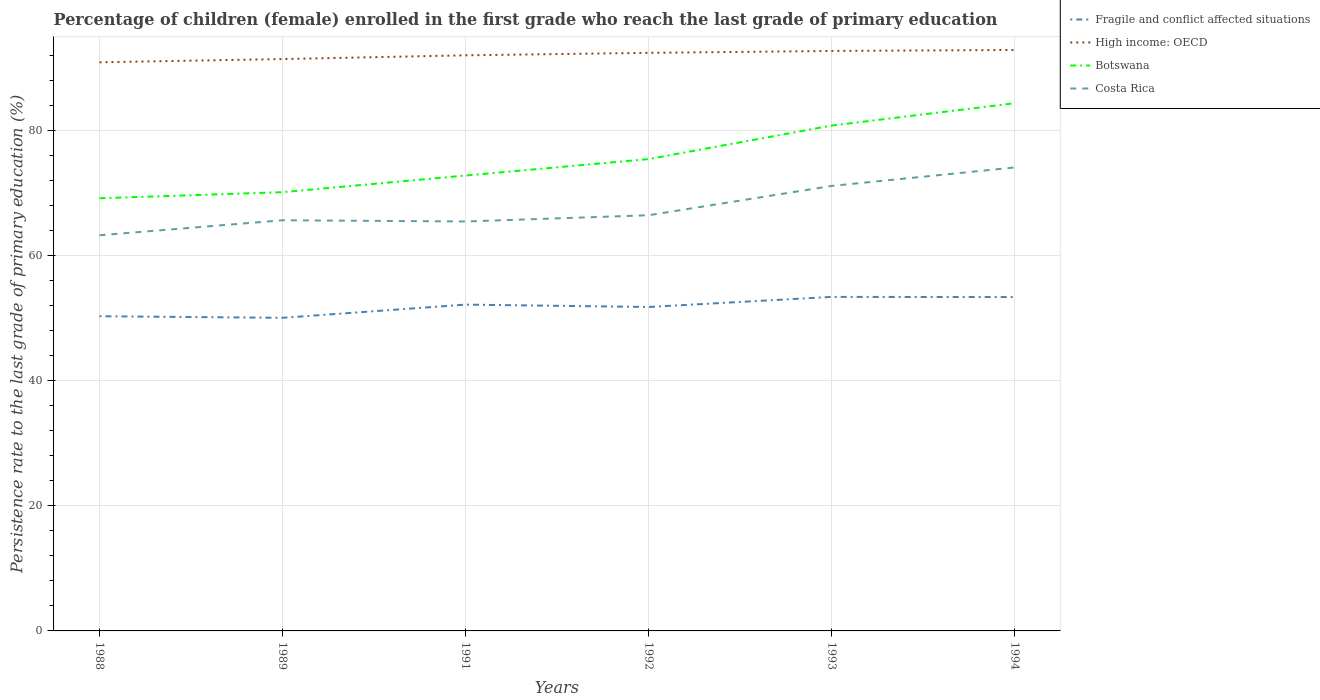How many different coloured lines are there?
Offer a very short reply. 4. Across all years, what is the maximum persistence rate of children in Botswana?
Ensure brevity in your answer.  69.21. In which year was the persistence rate of children in Fragile and conflict affected situations maximum?
Make the answer very short. 1989. What is the total persistence rate of children in Botswana in the graph?
Provide a succinct answer. -0.97. What is the difference between the highest and the second highest persistence rate of children in Botswana?
Offer a very short reply. 15.2. What is the difference between the highest and the lowest persistence rate of children in Fragile and conflict affected situations?
Your response must be concise. 3. What is the difference between two consecutive major ticks on the Y-axis?
Your answer should be very brief. 20. How are the legend labels stacked?
Give a very brief answer. Vertical. What is the title of the graph?
Offer a terse response. Percentage of children (female) enrolled in the first grade who reach the last grade of primary education. What is the label or title of the Y-axis?
Make the answer very short. Persistence rate to the last grade of primary education (%). What is the Persistence rate to the last grade of primary education (%) of Fragile and conflict affected situations in 1988?
Your response must be concise. 50.34. What is the Persistence rate to the last grade of primary education (%) in High income: OECD in 1988?
Provide a succinct answer. 90.96. What is the Persistence rate to the last grade of primary education (%) in Botswana in 1988?
Offer a very short reply. 69.21. What is the Persistence rate to the last grade of primary education (%) in Costa Rica in 1988?
Provide a succinct answer. 63.28. What is the Persistence rate to the last grade of primary education (%) in Fragile and conflict affected situations in 1989?
Ensure brevity in your answer.  50.08. What is the Persistence rate to the last grade of primary education (%) in High income: OECD in 1989?
Give a very brief answer. 91.47. What is the Persistence rate to the last grade of primary education (%) of Botswana in 1989?
Make the answer very short. 70.18. What is the Persistence rate to the last grade of primary education (%) in Costa Rica in 1989?
Offer a terse response. 65.69. What is the Persistence rate to the last grade of primary education (%) in Fragile and conflict affected situations in 1991?
Your response must be concise. 52.2. What is the Persistence rate to the last grade of primary education (%) of High income: OECD in 1991?
Offer a terse response. 92.07. What is the Persistence rate to the last grade of primary education (%) of Botswana in 1991?
Ensure brevity in your answer.  72.84. What is the Persistence rate to the last grade of primary education (%) of Costa Rica in 1991?
Provide a succinct answer. 65.49. What is the Persistence rate to the last grade of primary education (%) of Fragile and conflict affected situations in 1992?
Make the answer very short. 51.82. What is the Persistence rate to the last grade of primary education (%) in High income: OECD in 1992?
Offer a terse response. 92.47. What is the Persistence rate to the last grade of primary education (%) in Botswana in 1992?
Make the answer very short. 75.47. What is the Persistence rate to the last grade of primary education (%) in Costa Rica in 1992?
Your answer should be very brief. 66.49. What is the Persistence rate to the last grade of primary education (%) of Fragile and conflict affected situations in 1993?
Your answer should be compact. 53.43. What is the Persistence rate to the last grade of primary education (%) in High income: OECD in 1993?
Offer a terse response. 92.77. What is the Persistence rate to the last grade of primary education (%) of Botswana in 1993?
Your answer should be very brief. 80.83. What is the Persistence rate to the last grade of primary education (%) of Costa Rica in 1993?
Offer a very short reply. 71.18. What is the Persistence rate to the last grade of primary education (%) in Fragile and conflict affected situations in 1994?
Keep it short and to the point. 53.4. What is the Persistence rate to the last grade of primary education (%) in High income: OECD in 1994?
Provide a short and direct response. 92.93. What is the Persistence rate to the last grade of primary education (%) of Botswana in 1994?
Ensure brevity in your answer.  84.4. What is the Persistence rate to the last grade of primary education (%) in Costa Rica in 1994?
Ensure brevity in your answer.  74.13. Across all years, what is the maximum Persistence rate to the last grade of primary education (%) of Fragile and conflict affected situations?
Your answer should be compact. 53.43. Across all years, what is the maximum Persistence rate to the last grade of primary education (%) in High income: OECD?
Your answer should be compact. 92.93. Across all years, what is the maximum Persistence rate to the last grade of primary education (%) of Botswana?
Your answer should be very brief. 84.4. Across all years, what is the maximum Persistence rate to the last grade of primary education (%) of Costa Rica?
Your response must be concise. 74.13. Across all years, what is the minimum Persistence rate to the last grade of primary education (%) of Fragile and conflict affected situations?
Offer a terse response. 50.08. Across all years, what is the minimum Persistence rate to the last grade of primary education (%) in High income: OECD?
Offer a terse response. 90.96. Across all years, what is the minimum Persistence rate to the last grade of primary education (%) in Botswana?
Offer a very short reply. 69.21. Across all years, what is the minimum Persistence rate to the last grade of primary education (%) of Costa Rica?
Provide a succinct answer. 63.28. What is the total Persistence rate to the last grade of primary education (%) in Fragile and conflict affected situations in the graph?
Keep it short and to the point. 311.27. What is the total Persistence rate to the last grade of primary education (%) in High income: OECD in the graph?
Ensure brevity in your answer.  552.67. What is the total Persistence rate to the last grade of primary education (%) in Botswana in the graph?
Your answer should be very brief. 452.94. What is the total Persistence rate to the last grade of primary education (%) of Costa Rica in the graph?
Your answer should be very brief. 406.27. What is the difference between the Persistence rate to the last grade of primary education (%) in Fragile and conflict affected situations in 1988 and that in 1989?
Give a very brief answer. 0.26. What is the difference between the Persistence rate to the last grade of primary education (%) of High income: OECD in 1988 and that in 1989?
Provide a succinct answer. -0.51. What is the difference between the Persistence rate to the last grade of primary education (%) in Botswana in 1988 and that in 1989?
Keep it short and to the point. -0.97. What is the difference between the Persistence rate to the last grade of primary education (%) of Costa Rica in 1988 and that in 1989?
Keep it short and to the point. -2.4. What is the difference between the Persistence rate to the last grade of primary education (%) in Fragile and conflict affected situations in 1988 and that in 1991?
Your response must be concise. -1.86. What is the difference between the Persistence rate to the last grade of primary education (%) of High income: OECD in 1988 and that in 1991?
Offer a very short reply. -1.12. What is the difference between the Persistence rate to the last grade of primary education (%) in Botswana in 1988 and that in 1991?
Your answer should be compact. -3.64. What is the difference between the Persistence rate to the last grade of primary education (%) of Costa Rica in 1988 and that in 1991?
Make the answer very short. -2.21. What is the difference between the Persistence rate to the last grade of primary education (%) in Fragile and conflict affected situations in 1988 and that in 1992?
Your answer should be compact. -1.48. What is the difference between the Persistence rate to the last grade of primary education (%) in High income: OECD in 1988 and that in 1992?
Keep it short and to the point. -1.51. What is the difference between the Persistence rate to the last grade of primary education (%) of Botswana in 1988 and that in 1992?
Make the answer very short. -6.27. What is the difference between the Persistence rate to the last grade of primary education (%) in Costa Rica in 1988 and that in 1992?
Provide a short and direct response. -3.21. What is the difference between the Persistence rate to the last grade of primary education (%) in Fragile and conflict affected situations in 1988 and that in 1993?
Your answer should be very brief. -3.09. What is the difference between the Persistence rate to the last grade of primary education (%) in High income: OECD in 1988 and that in 1993?
Provide a short and direct response. -1.81. What is the difference between the Persistence rate to the last grade of primary education (%) of Botswana in 1988 and that in 1993?
Make the answer very short. -11.63. What is the difference between the Persistence rate to the last grade of primary education (%) of Costa Rica in 1988 and that in 1993?
Provide a succinct answer. -7.89. What is the difference between the Persistence rate to the last grade of primary education (%) of Fragile and conflict affected situations in 1988 and that in 1994?
Keep it short and to the point. -3.06. What is the difference between the Persistence rate to the last grade of primary education (%) of High income: OECD in 1988 and that in 1994?
Keep it short and to the point. -1.97. What is the difference between the Persistence rate to the last grade of primary education (%) in Botswana in 1988 and that in 1994?
Keep it short and to the point. -15.2. What is the difference between the Persistence rate to the last grade of primary education (%) in Costa Rica in 1988 and that in 1994?
Provide a short and direct response. -10.85. What is the difference between the Persistence rate to the last grade of primary education (%) in Fragile and conflict affected situations in 1989 and that in 1991?
Your response must be concise. -2.11. What is the difference between the Persistence rate to the last grade of primary education (%) in High income: OECD in 1989 and that in 1991?
Provide a succinct answer. -0.6. What is the difference between the Persistence rate to the last grade of primary education (%) of Botswana in 1989 and that in 1991?
Ensure brevity in your answer.  -2.66. What is the difference between the Persistence rate to the last grade of primary education (%) in Costa Rica in 1989 and that in 1991?
Your response must be concise. 0.2. What is the difference between the Persistence rate to the last grade of primary education (%) in Fragile and conflict affected situations in 1989 and that in 1992?
Ensure brevity in your answer.  -1.73. What is the difference between the Persistence rate to the last grade of primary education (%) in High income: OECD in 1989 and that in 1992?
Your response must be concise. -0.99. What is the difference between the Persistence rate to the last grade of primary education (%) in Botswana in 1989 and that in 1992?
Your answer should be compact. -5.29. What is the difference between the Persistence rate to the last grade of primary education (%) of Costa Rica in 1989 and that in 1992?
Provide a short and direct response. -0.8. What is the difference between the Persistence rate to the last grade of primary education (%) of Fragile and conflict affected situations in 1989 and that in 1993?
Offer a very short reply. -3.35. What is the difference between the Persistence rate to the last grade of primary education (%) in High income: OECD in 1989 and that in 1993?
Offer a terse response. -1.3. What is the difference between the Persistence rate to the last grade of primary education (%) of Botswana in 1989 and that in 1993?
Ensure brevity in your answer.  -10.65. What is the difference between the Persistence rate to the last grade of primary education (%) of Costa Rica in 1989 and that in 1993?
Your response must be concise. -5.49. What is the difference between the Persistence rate to the last grade of primary education (%) of Fragile and conflict affected situations in 1989 and that in 1994?
Your response must be concise. -3.32. What is the difference between the Persistence rate to the last grade of primary education (%) of High income: OECD in 1989 and that in 1994?
Give a very brief answer. -1.46. What is the difference between the Persistence rate to the last grade of primary education (%) in Botswana in 1989 and that in 1994?
Your response must be concise. -14.22. What is the difference between the Persistence rate to the last grade of primary education (%) of Costa Rica in 1989 and that in 1994?
Ensure brevity in your answer.  -8.44. What is the difference between the Persistence rate to the last grade of primary education (%) of Fragile and conflict affected situations in 1991 and that in 1992?
Your answer should be very brief. 0.38. What is the difference between the Persistence rate to the last grade of primary education (%) in High income: OECD in 1991 and that in 1992?
Your response must be concise. -0.39. What is the difference between the Persistence rate to the last grade of primary education (%) in Botswana in 1991 and that in 1992?
Provide a short and direct response. -2.63. What is the difference between the Persistence rate to the last grade of primary education (%) in Costa Rica in 1991 and that in 1992?
Keep it short and to the point. -1. What is the difference between the Persistence rate to the last grade of primary education (%) of Fragile and conflict affected situations in 1991 and that in 1993?
Provide a succinct answer. -1.23. What is the difference between the Persistence rate to the last grade of primary education (%) in High income: OECD in 1991 and that in 1993?
Your answer should be compact. -0.7. What is the difference between the Persistence rate to the last grade of primary education (%) in Botswana in 1991 and that in 1993?
Your answer should be compact. -7.99. What is the difference between the Persistence rate to the last grade of primary education (%) of Costa Rica in 1991 and that in 1993?
Give a very brief answer. -5.68. What is the difference between the Persistence rate to the last grade of primary education (%) of Fragile and conflict affected situations in 1991 and that in 1994?
Your answer should be very brief. -1.21. What is the difference between the Persistence rate to the last grade of primary education (%) in High income: OECD in 1991 and that in 1994?
Your answer should be very brief. -0.85. What is the difference between the Persistence rate to the last grade of primary education (%) in Botswana in 1991 and that in 1994?
Ensure brevity in your answer.  -11.56. What is the difference between the Persistence rate to the last grade of primary education (%) in Costa Rica in 1991 and that in 1994?
Your answer should be very brief. -8.64. What is the difference between the Persistence rate to the last grade of primary education (%) of Fragile and conflict affected situations in 1992 and that in 1993?
Provide a succinct answer. -1.61. What is the difference between the Persistence rate to the last grade of primary education (%) of High income: OECD in 1992 and that in 1993?
Your answer should be very brief. -0.3. What is the difference between the Persistence rate to the last grade of primary education (%) of Botswana in 1992 and that in 1993?
Your answer should be compact. -5.36. What is the difference between the Persistence rate to the last grade of primary education (%) in Costa Rica in 1992 and that in 1993?
Make the answer very short. -4.69. What is the difference between the Persistence rate to the last grade of primary education (%) in Fragile and conflict affected situations in 1992 and that in 1994?
Give a very brief answer. -1.59. What is the difference between the Persistence rate to the last grade of primary education (%) in High income: OECD in 1992 and that in 1994?
Give a very brief answer. -0.46. What is the difference between the Persistence rate to the last grade of primary education (%) in Botswana in 1992 and that in 1994?
Provide a succinct answer. -8.93. What is the difference between the Persistence rate to the last grade of primary education (%) of Costa Rica in 1992 and that in 1994?
Ensure brevity in your answer.  -7.64. What is the difference between the Persistence rate to the last grade of primary education (%) in Fragile and conflict affected situations in 1993 and that in 1994?
Give a very brief answer. 0.03. What is the difference between the Persistence rate to the last grade of primary education (%) in High income: OECD in 1993 and that in 1994?
Provide a short and direct response. -0.16. What is the difference between the Persistence rate to the last grade of primary education (%) of Botswana in 1993 and that in 1994?
Offer a terse response. -3.57. What is the difference between the Persistence rate to the last grade of primary education (%) of Costa Rica in 1993 and that in 1994?
Offer a very short reply. -2.96. What is the difference between the Persistence rate to the last grade of primary education (%) in Fragile and conflict affected situations in 1988 and the Persistence rate to the last grade of primary education (%) in High income: OECD in 1989?
Ensure brevity in your answer.  -41.13. What is the difference between the Persistence rate to the last grade of primary education (%) of Fragile and conflict affected situations in 1988 and the Persistence rate to the last grade of primary education (%) of Botswana in 1989?
Your answer should be compact. -19.84. What is the difference between the Persistence rate to the last grade of primary education (%) in Fragile and conflict affected situations in 1988 and the Persistence rate to the last grade of primary education (%) in Costa Rica in 1989?
Provide a short and direct response. -15.35. What is the difference between the Persistence rate to the last grade of primary education (%) in High income: OECD in 1988 and the Persistence rate to the last grade of primary education (%) in Botswana in 1989?
Provide a succinct answer. 20.78. What is the difference between the Persistence rate to the last grade of primary education (%) of High income: OECD in 1988 and the Persistence rate to the last grade of primary education (%) of Costa Rica in 1989?
Your response must be concise. 25.27. What is the difference between the Persistence rate to the last grade of primary education (%) of Botswana in 1988 and the Persistence rate to the last grade of primary education (%) of Costa Rica in 1989?
Provide a short and direct response. 3.52. What is the difference between the Persistence rate to the last grade of primary education (%) in Fragile and conflict affected situations in 1988 and the Persistence rate to the last grade of primary education (%) in High income: OECD in 1991?
Your answer should be very brief. -41.73. What is the difference between the Persistence rate to the last grade of primary education (%) of Fragile and conflict affected situations in 1988 and the Persistence rate to the last grade of primary education (%) of Botswana in 1991?
Offer a terse response. -22.5. What is the difference between the Persistence rate to the last grade of primary education (%) of Fragile and conflict affected situations in 1988 and the Persistence rate to the last grade of primary education (%) of Costa Rica in 1991?
Your answer should be compact. -15.15. What is the difference between the Persistence rate to the last grade of primary education (%) of High income: OECD in 1988 and the Persistence rate to the last grade of primary education (%) of Botswana in 1991?
Offer a terse response. 18.12. What is the difference between the Persistence rate to the last grade of primary education (%) in High income: OECD in 1988 and the Persistence rate to the last grade of primary education (%) in Costa Rica in 1991?
Your response must be concise. 25.46. What is the difference between the Persistence rate to the last grade of primary education (%) of Botswana in 1988 and the Persistence rate to the last grade of primary education (%) of Costa Rica in 1991?
Make the answer very short. 3.71. What is the difference between the Persistence rate to the last grade of primary education (%) of Fragile and conflict affected situations in 1988 and the Persistence rate to the last grade of primary education (%) of High income: OECD in 1992?
Your response must be concise. -42.13. What is the difference between the Persistence rate to the last grade of primary education (%) of Fragile and conflict affected situations in 1988 and the Persistence rate to the last grade of primary education (%) of Botswana in 1992?
Your response must be concise. -25.13. What is the difference between the Persistence rate to the last grade of primary education (%) of Fragile and conflict affected situations in 1988 and the Persistence rate to the last grade of primary education (%) of Costa Rica in 1992?
Ensure brevity in your answer.  -16.15. What is the difference between the Persistence rate to the last grade of primary education (%) of High income: OECD in 1988 and the Persistence rate to the last grade of primary education (%) of Botswana in 1992?
Offer a very short reply. 15.49. What is the difference between the Persistence rate to the last grade of primary education (%) of High income: OECD in 1988 and the Persistence rate to the last grade of primary education (%) of Costa Rica in 1992?
Your answer should be very brief. 24.47. What is the difference between the Persistence rate to the last grade of primary education (%) in Botswana in 1988 and the Persistence rate to the last grade of primary education (%) in Costa Rica in 1992?
Keep it short and to the point. 2.72. What is the difference between the Persistence rate to the last grade of primary education (%) of Fragile and conflict affected situations in 1988 and the Persistence rate to the last grade of primary education (%) of High income: OECD in 1993?
Your answer should be very brief. -42.43. What is the difference between the Persistence rate to the last grade of primary education (%) of Fragile and conflict affected situations in 1988 and the Persistence rate to the last grade of primary education (%) of Botswana in 1993?
Your answer should be compact. -30.49. What is the difference between the Persistence rate to the last grade of primary education (%) of Fragile and conflict affected situations in 1988 and the Persistence rate to the last grade of primary education (%) of Costa Rica in 1993?
Your answer should be compact. -20.84. What is the difference between the Persistence rate to the last grade of primary education (%) of High income: OECD in 1988 and the Persistence rate to the last grade of primary education (%) of Botswana in 1993?
Provide a succinct answer. 10.12. What is the difference between the Persistence rate to the last grade of primary education (%) in High income: OECD in 1988 and the Persistence rate to the last grade of primary education (%) in Costa Rica in 1993?
Provide a succinct answer. 19.78. What is the difference between the Persistence rate to the last grade of primary education (%) of Botswana in 1988 and the Persistence rate to the last grade of primary education (%) of Costa Rica in 1993?
Your answer should be very brief. -1.97. What is the difference between the Persistence rate to the last grade of primary education (%) of Fragile and conflict affected situations in 1988 and the Persistence rate to the last grade of primary education (%) of High income: OECD in 1994?
Offer a very short reply. -42.59. What is the difference between the Persistence rate to the last grade of primary education (%) in Fragile and conflict affected situations in 1988 and the Persistence rate to the last grade of primary education (%) in Botswana in 1994?
Ensure brevity in your answer.  -34.07. What is the difference between the Persistence rate to the last grade of primary education (%) of Fragile and conflict affected situations in 1988 and the Persistence rate to the last grade of primary education (%) of Costa Rica in 1994?
Make the answer very short. -23.79. What is the difference between the Persistence rate to the last grade of primary education (%) in High income: OECD in 1988 and the Persistence rate to the last grade of primary education (%) in Botswana in 1994?
Your answer should be very brief. 6.55. What is the difference between the Persistence rate to the last grade of primary education (%) in High income: OECD in 1988 and the Persistence rate to the last grade of primary education (%) in Costa Rica in 1994?
Offer a very short reply. 16.83. What is the difference between the Persistence rate to the last grade of primary education (%) of Botswana in 1988 and the Persistence rate to the last grade of primary education (%) of Costa Rica in 1994?
Give a very brief answer. -4.93. What is the difference between the Persistence rate to the last grade of primary education (%) of Fragile and conflict affected situations in 1989 and the Persistence rate to the last grade of primary education (%) of High income: OECD in 1991?
Provide a succinct answer. -41.99. What is the difference between the Persistence rate to the last grade of primary education (%) in Fragile and conflict affected situations in 1989 and the Persistence rate to the last grade of primary education (%) in Botswana in 1991?
Provide a succinct answer. -22.76. What is the difference between the Persistence rate to the last grade of primary education (%) in Fragile and conflict affected situations in 1989 and the Persistence rate to the last grade of primary education (%) in Costa Rica in 1991?
Offer a terse response. -15.41. What is the difference between the Persistence rate to the last grade of primary education (%) of High income: OECD in 1989 and the Persistence rate to the last grade of primary education (%) of Botswana in 1991?
Your answer should be very brief. 18.63. What is the difference between the Persistence rate to the last grade of primary education (%) of High income: OECD in 1989 and the Persistence rate to the last grade of primary education (%) of Costa Rica in 1991?
Provide a succinct answer. 25.98. What is the difference between the Persistence rate to the last grade of primary education (%) of Botswana in 1989 and the Persistence rate to the last grade of primary education (%) of Costa Rica in 1991?
Provide a succinct answer. 4.69. What is the difference between the Persistence rate to the last grade of primary education (%) in Fragile and conflict affected situations in 1989 and the Persistence rate to the last grade of primary education (%) in High income: OECD in 1992?
Make the answer very short. -42.38. What is the difference between the Persistence rate to the last grade of primary education (%) of Fragile and conflict affected situations in 1989 and the Persistence rate to the last grade of primary education (%) of Botswana in 1992?
Provide a succinct answer. -25.39. What is the difference between the Persistence rate to the last grade of primary education (%) in Fragile and conflict affected situations in 1989 and the Persistence rate to the last grade of primary education (%) in Costa Rica in 1992?
Offer a very short reply. -16.41. What is the difference between the Persistence rate to the last grade of primary education (%) in High income: OECD in 1989 and the Persistence rate to the last grade of primary education (%) in Botswana in 1992?
Offer a very short reply. 16. What is the difference between the Persistence rate to the last grade of primary education (%) of High income: OECD in 1989 and the Persistence rate to the last grade of primary education (%) of Costa Rica in 1992?
Provide a succinct answer. 24.98. What is the difference between the Persistence rate to the last grade of primary education (%) of Botswana in 1989 and the Persistence rate to the last grade of primary education (%) of Costa Rica in 1992?
Offer a very short reply. 3.69. What is the difference between the Persistence rate to the last grade of primary education (%) of Fragile and conflict affected situations in 1989 and the Persistence rate to the last grade of primary education (%) of High income: OECD in 1993?
Your response must be concise. -42.69. What is the difference between the Persistence rate to the last grade of primary education (%) of Fragile and conflict affected situations in 1989 and the Persistence rate to the last grade of primary education (%) of Botswana in 1993?
Offer a very short reply. -30.75. What is the difference between the Persistence rate to the last grade of primary education (%) of Fragile and conflict affected situations in 1989 and the Persistence rate to the last grade of primary education (%) of Costa Rica in 1993?
Your answer should be compact. -21.09. What is the difference between the Persistence rate to the last grade of primary education (%) of High income: OECD in 1989 and the Persistence rate to the last grade of primary education (%) of Botswana in 1993?
Offer a very short reply. 10.64. What is the difference between the Persistence rate to the last grade of primary education (%) in High income: OECD in 1989 and the Persistence rate to the last grade of primary education (%) in Costa Rica in 1993?
Provide a succinct answer. 20.3. What is the difference between the Persistence rate to the last grade of primary education (%) of Botswana in 1989 and the Persistence rate to the last grade of primary education (%) of Costa Rica in 1993?
Give a very brief answer. -1. What is the difference between the Persistence rate to the last grade of primary education (%) of Fragile and conflict affected situations in 1989 and the Persistence rate to the last grade of primary education (%) of High income: OECD in 1994?
Offer a very short reply. -42.84. What is the difference between the Persistence rate to the last grade of primary education (%) in Fragile and conflict affected situations in 1989 and the Persistence rate to the last grade of primary education (%) in Botswana in 1994?
Offer a terse response. -34.32. What is the difference between the Persistence rate to the last grade of primary education (%) in Fragile and conflict affected situations in 1989 and the Persistence rate to the last grade of primary education (%) in Costa Rica in 1994?
Your answer should be very brief. -24.05. What is the difference between the Persistence rate to the last grade of primary education (%) of High income: OECD in 1989 and the Persistence rate to the last grade of primary education (%) of Botswana in 1994?
Make the answer very short. 7.07. What is the difference between the Persistence rate to the last grade of primary education (%) in High income: OECD in 1989 and the Persistence rate to the last grade of primary education (%) in Costa Rica in 1994?
Make the answer very short. 17.34. What is the difference between the Persistence rate to the last grade of primary education (%) in Botswana in 1989 and the Persistence rate to the last grade of primary education (%) in Costa Rica in 1994?
Provide a short and direct response. -3.95. What is the difference between the Persistence rate to the last grade of primary education (%) in Fragile and conflict affected situations in 1991 and the Persistence rate to the last grade of primary education (%) in High income: OECD in 1992?
Your response must be concise. -40.27. What is the difference between the Persistence rate to the last grade of primary education (%) of Fragile and conflict affected situations in 1991 and the Persistence rate to the last grade of primary education (%) of Botswana in 1992?
Offer a very short reply. -23.28. What is the difference between the Persistence rate to the last grade of primary education (%) of Fragile and conflict affected situations in 1991 and the Persistence rate to the last grade of primary education (%) of Costa Rica in 1992?
Make the answer very short. -14.29. What is the difference between the Persistence rate to the last grade of primary education (%) of High income: OECD in 1991 and the Persistence rate to the last grade of primary education (%) of Botswana in 1992?
Give a very brief answer. 16.6. What is the difference between the Persistence rate to the last grade of primary education (%) in High income: OECD in 1991 and the Persistence rate to the last grade of primary education (%) in Costa Rica in 1992?
Your answer should be compact. 25.58. What is the difference between the Persistence rate to the last grade of primary education (%) of Botswana in 1991 and the Persistence rate to the last grade of primary education (%) of Costa Rica in 1992?
Make the answer very short. 6.35. What is the difference between the Persistence rate to the last grade of primary education (%) of Fragile and conflict affected situations in 1991 and the Persistence rate to the last grade of primary education (%) of High income: OECD in 1993?
Your response must be concise. -40.57. What is the difference between the Persistence rate to the last grade of primary education (%) of Fragile and conflict affected situations in 1991 and the Persistence rate to the last grade of primary education (%) of Botswana in 1993?
Your response must be concise. -28.64. What is the difference between the Persistence rate to the last grade of primary education (%) of Fragile and conflict affected situations in 1991 and the Persistence rate to the last grade of primary education (%) of Costa Rica in 1993?
Your answer should be very brief. -18.98. What is the difference between the Persistence rate to the last grade of primary education (%) in High income: OECD in 1991 and the Persistence rate to the last grade of primary education (%) in Botswana in 1993?
Your response must be concise. 11.24. What is the difference between the Persistence rate to the last grade of primary education (%) in High income: OECD in 1991 and the Persistence rate to the last grade of primary education (%) in Costa Rica in 1993?
Your answer should be very brief. 20.9. What is the difference between the Persistence rate to the last grade of primary education (%) of Botswana in 1991 and the Persistence rate to the last grade of primary education (%) of Costa Rica in 1993?
Ensure brevity in your answer.  1.67. What is the difference between the Persistence rate to the last grade of primary education (%) of Fragile and conflict affected situations in 1991 and the Persistence rate to the last grade of primary education (%) of High income: OECD in 1994?
Offer a very short reply. -40.73. What is the difference between the Persistence rate to the last grade of primary education (%) of Fragile and conflict affected situations in 1991 and the Persistence rate to the last grade of primary education (%) of Botswana in 1994?
Ensure brevity in your answer.  -32.21. What is the difference between the Persistence rate to the last grade of primary education (%) of Fragile and conflict affected situations in 1991 and the Persistence rate to the last grade of primary education (%) of Costa Rica in 1994?
Provide a short and direct response. -21.94. What is the difference between the Persistence rate to the last grade of primary education (%) in High income: OECD in 1991 and the Persistence rate to the last grade of primary education (%) in Botswana in 1994?
Offer a very short reply. 7.67. What is the difference between the Persistence rate to the last grade of primary education (%) of High income: OECD in 1991 and the Persistence rate to the last grade of primary education (%) of Costa Rica in 1994?
Provide a short and direct response. 17.94. What is the difference between the Persistence rate to the last grade of primary education (%) in Botswana in 1991 and the Persistence rate to the last grade of primary education (%) in Costa Rica in 1994?
Your response must be concise. -1.29. What is the difference between the Persistence rate to the last grade of primary education (%) in Fragile and conflict affected situations in 1992 and the Persistence rate to the last grade of primary education (%) in High income: OECD in 1993?
Your response must be concise. -40.95. What is the difference between the Persistence rate to the last grade of primary education (%) of Fragile and conflict affected situations in 1992 and the Persistence rate to the last grade of primary education (%) of Botswana in 1993?
Your response must be concise. -29.02. What is the difference between the Persistence rate to the last grade of primary education (%) in Fragile and conflict affected situations in 1992 and the Persistence rate to the last grade of primary education (%) in Costa Rica in 1993?
Your answer should be very brief. -19.36. What is the difference between the Persistence rate to the last grade of primary education (%) of High income: OECD in 1992 and the Persistence rate to the last grade of primary education (%) of Botswana in 1993?
Provide a short and direct response. 11.63. What is the difference between the Persistence rate to the last grade of primary education (%) of High income: OECD in 1992 and the Persistence rate to the last grade of primary education (%) of Costa Rica in 1993?
Offer a terse response. 21.29. What is the difference between the Persistence rate to the last grade of primary education (%) of Botswana in 1992 and the Persistence rate to the last grade of primary education (%) of Costa Rica in 1993?
Ensure brevity in your answer.  4.3. What is the difference between the Persistence rate to the last grade of primary education (%) of Fragile and conflict affected situations in 1992 and the Persistence rate to the last grade of primary education (%) of High income: OECD in 1994?
Your answer should be very brief. -41.11. What is the difference between the Persistence rate to the last grade of primary education (%) in Fragile and conflict affected situations in 1992 and the Persistence rate to the last grade of primary education (%) in Botswana in 1994?
Keep it short and to the point. -32.59. What is the difference between the Persistence rate to the last grade of primary education (%) of Fragile and conflict affected situations in 1992 and the Persistence rate to the last grade of primary education (%) of Costa Rica in 1994?
Offer a very short reply. -22.32. What is the difference between the Persistence rate to the last grade of primary education (%) of High income: OECD in 1992 and the Persistence rate to the last grade of primary education (%) of Botswana in 1994?
Offer a terse response. 8.06. What is the difference between the Persistence rate to the last grade of primary education (%) in High income: OECD in 1992 and the Persistence rate to the last grade of primary education (%) in Costa Rica in 1994?
Offer a very short reply. 18.33. What is the difference between the Persistence rate to the last grade of primary education (%) in Botswana in 1992 and the Persistence rate to the last grade of primary education (%) in Costa Rica in 1994?
Offer a very short reply. 1.34. What is the difference between the Persistence rate to the last grade of primary education (%) of Fragile and conflict affected situations in 1993 and the Persistence rate to the last grade of primary education (%) of High income: OECD in 1994?
Ensure brevity in your answer.  -39.5. What is the difference between the Persistence rate to the last grade of primary education (%) of Fragile and conflict affected situations in 1993 and the Persistence rate to the last grade of primary education (%) of Botswana in 1994?
Provide a short and direct response. -30.98. What is the difference between the Persistence rate to the last grade of primary education (%) in Fragile and conflict affected situations in 1993 and the Persistence rate to the last grade of primary education (%) in Costa Rica in 1994?
Ensure brevity in your answer.  -20.7. What is the difference between the Persistence rate to the last grade of primary education (%) in High income: OECD in 1993 and the Persistence rate to the last grade of primary education (%) in Botswana in 1994?
Your answer should be very brief. 8.37. What is the difference between the Persistence rate to the last grade of primary education (%) in High income: OECD in 1993 and the Persistence rate to the last grade of primary education (%) in Costa Rica in 1994?
Keep it short and to the point. 18.64. What is the difference between the Persistence rate to the last grade of primary education (%) in Botswana in 1993 and the Persistence rate to the last grade of primary education (%) in Costa Rica in 1994?
Offer a terse response. 6.7. What is the average Persistence rate to the last grade of primary education (%) in Fragile and conflict affected situations per year?
Keep it short and to the point. 51.88. What is the average Persistence rate to the last grade of primary education (%) in High income: OECD per year?
Keep it short and to the point. 92.11. What is the average Persistence rate to the last grade of primary education (%) in Botswana per year?
Your answer should be very brief. 75.49. What is the average Persistence rate to the last grade of primary education (%) of Costa Rica per year?
Offer a very short reply. 67.71. In the year 1988, what is the difference between the Persistence rate to the last grade of primary education (%) of Fragile and conflict affected situations and Persistence rate to the last grade of primary education (%) of High income: OECD?
Your answer should be compact. -40.62. In the year 1988, what is the difference between the Persistence rate to the last grade of primary education (%) in Fragile and conflict affected situations and Persistence rate to the last grade of primary education (%) in Botswana?
Offer a very short reply. -18.87. In the year 1988, what is the difference between the Persistence rate to the last grade of primary education (%) of Fragile and conflict affected situations and Persistence rate to the last grade of primary education (%) of Costa Rica?
Offer a terse response. -12.95. In the year 1988, what is the difference between the Persistence rate to the last grade of primary education (%) of High income: OECD and Persistence rate to the last grade of primary education (%) of Botswana?
Make the answer very short. 21.75. In the year 1988, what is the difference between the Persistence rate to the last grade of primary education (%) of High income: OECD and Persistence rate to the last grade of primary education (%) of Costa Rica?
Your answer should be compact. 27.67. In the year 1988, what is the difference between the Persistence rate to the last grade of primary education (%) of Botswana and Persistence rate to the last grade of primary education (%) of Costa Rica?
Provide a short and direct response. 5.92. In the year 1989, what is the difference between the Persistence rate to the last grade of primary education (%) of Fragile and conflict affected situations and Persistence rate to the last grade of primary education (%) of High income: OECD?
Provide a succinct answer. -41.39. In the year 1989, what is the difference between the Persistence rate to the last grade of primary education (%) in Fragile and conflict affected situations and Persistence rate to the last grade of primary education (%) in Botswana?
Your answer should be compact. -20.1. In the year 1989, what is the difference between the Persistence rate to the last grade of primary education (%) of Fragile and conflict affected situations and Persistence rate to the last grade of primary education (%) of Costa Rica?
Ensure brevity in your answer.  -15.61. In the year 1989, what is the difference between the Persistence rate to the last grade of primary education (%) of High income: OECD and Persistence rate to the last grade of primary education (%) of Botswana?
Offer a terse response. 21.29. In the year 1989, what is the difference between the Persistence rate to the last grade of primary education (%) in High income: OECD and Persistence rate to the last grade of primary education (%) in Costa Rica?
Ensure brevity in your answer.  25.78. In the year 1989, what is the difference between the Persistence rate to the last grade of primary education (%) of Botswana and Persistence rate to the last grade of primary education (%) of Costa Rica?
Offer a terse response. 4.49. In the year 1991, what is the difference between the Persistence rate to the last grade of primary education (%) in Fragile and conflict affected situations and Persistence rate to the last grade of primary education (%) in High income: OECD?
Keep it short and to the point. -39.88. In the year 1991, what is the difference between the Persistence rate to the last grade of primary education (%) of Fragile and conflict affected situations and Persistence rate to the last grade of primary education (%) of Botswana?
Your answer should be compact. -20.65. In the year 1991, what is the difference between the Persistence rate to the last grade of primary education (%) in Fragile and conflict affected situations and Persistence rate to the last grade of primary education (%) in Costa Rica?
Give a very brief answer. -13.3. In the year 1991, what is the difference between the Persistence rate to the last grade of primary education (%) in High income: OECD and Persistence rate to the last grade of primary education (%) in Botswana?
Your answer should be very brief. 19.23. In the year 1991, what is the difference between the Persistence rate to the last grade of primary education (%) of High income: OECD and Persistence rate to the last grade of primary education (%) of Costa Rica?
Your answer should be compact. 26.58. In the year 1991, what is the difference between the Persistence rate to the last grade of primary education (%) of Botswana and Persistence rate to the last grade of primary education (%) of Costa Rica?
Provide a short and direct response. 7.35. In the year 1992, what is the difference between the Persistence rate to the last grade of primary education (%) in Fragile and conflict affected situations and Persistence rate to the last grade of primary education (%) in High income: OECD?
Offer a terse response. -40.65. In the year 1992, what is the difference between the Persistence rate to the last grade of primary education (%) in Fragile and conflict affected situations and Persistence rate to the last grade of primary education (%) in Botswana?
Provide a short and direct response. -23.66. In the year 1992, what is the difference between the Persistence rate to the last grade of primary education (%) of Fragile and conflict affected situations and Persistence rate to the last grade of primary education (%) of Costa Rica?
Your answer should be compact. -14.67. In the year 1992, what is the difference between the Persistence rate to the last grade of primary education (%) in High income: OECD and Persistence rate to the last grade of primary education (%) in Botswana?
Offer a very short reply. 16.99. In the year 1992, what is the difference between the Persistence rate to the last grade of primary education (%) in High income: OECD and Persistence rate to the last grade of primary education (%) in Costa Rica?
Your response must be concise. 25.98. In the year 1992, what is the difference between the Persistence rate to the last grade of primary education (%) in Botswana and Persistence rate to the last grade of primary education (%) in Costa Rica?
Offer a terse response. 8.98. In the year 1993, what is the difference between the Persistence rate to the last grade of primary education (%) of Fragile and conflict affected situations and Persistence rate to the last grade of primary education (%) of High income: OECD?
Make the answer very short. -39.34. In the year 1993, what is the difference between the Persistence rate to the last grade of primary education (%) of Fragile and conflict affected situations and Persistence rate to the last grade of primary education (%) of Botswana?
Offer a terse response. -27.4. In the year 1993, what is the difference between the Persistence rate to the last grade of primary education (%) in Fragile and conflict affected situations and Persistence rate to the last grade of primary education (%) in Costa Rica?
Provide a short and direct response. -17.75. In the year 1993, what is the difference between the Persistence rate to the last grade of primary education (%) of High income: OECD and Persistence rate to the last grade of primary education (%) of Botswana?
Provide a short and direct response. 11.94. In the year 1993, what is the difference between the Persistence rate to the last grade of primary education (%) in High income: OECD and Persistence rate to the last grade of primary education (%) in Costa Rica?
Keep it short and to the point. 21.59. In the year 1993, what is the difference between the Persistence rate to the last grade of primary education (%) in Botswana and Persistence rate to the last grade of primary education (%) in Costa Rica?
Your answer should be compact. 9.66. In the year 1994, what is the difference between the Persistence rate to the last grade of primary education (%) in Fragile and conflict affected situations and Persistence rate to the last grade of primary education (%) in High income: OECD?
Your answer should be very brief. -39.52. In the year 1994, what is the difference between the Persistence rate to the last grade of primary education (%) of Fragile and conflict affected situations and Persistence rate to the last grade of primary education (%) of Botswana?
Ensure brevity in your answer.  -31. In the year 1994, what is the difference between the Persistence rate to the last grade of primary education (%) of Fragile and conflict affected situations and Persistence rate to the last grade of primary education (%) of Costa Rica?
Make the answer very short. -20.73. In the year 1994, what is the difference between the Persistence rate to the last grade of primary education (%) in High income: OECD and Persistence rate to the last grade of primary education (%) in Botswana?
Give a very brief answer. 8.52. In the year 1994, what is the difference between the Persistence rate to the last grade of primary education (%) in High income: OECD and Persistence rate to the last grade of primary education (%) in Costa Rica?
Provide a short and direct response. 18.8. In the year 1994, what is the difference between the Persistence rate to the last grade of primary education (%) of Botswana and Persistence rate to the last grade of primary education (%) of Costa Rica?
Keep it short and to the point. 10.27. What is the ratio of the Persistence rate to the last grade of primary education (%) in Fragile and conflict affected situations in 1988 to that in 1989?
Offer a very short reply. 1.01. What is the ratio of the Persistence rate to the last grade of primary education (%) in Botswana in 1988 to that in 1989?
Provide a succinct answer. 0.99. What is the ratio of the Persistence rate to the last grade of primary education (%) of Costa Rica in 1988 to that in 1989?
Your answer should be compact. 0.96. What is the ratio of the Persistence rate to the last grade of primary education (%) of Fragile and conflict affected situations in 1988 to that in 1991?
Keep it short and to the point. 0.96. What is the ratio of the Persistence rate to the last grade of primary education (%) in High income: OECD in 1988 to that in 1991?
Offer a terse response. 0.99. What is the ratio of the Persistence rate to the last grade of primary education (%) in Botswana in 1988 to that in 1991?
Offer a terse response. 0.95. What is the ratio of the Persistence rate to the last grade of primary education (%) in Costa Rica in 1988 to that in 1991?
Your answer should be compact. 0.97. What is the ratio of the Persistence rate to the last grade of primary education (%) in Fragile and conflict affected situations in 1988 to that in 1992?
Your answer should be very brief. 0.97. What is the ratio of the Persistence rate to the last grade of primary education (%) in High income: OECD in 1988 to that in 1992?
Your answer should be compact. 0.98. What is the ratio of the Persistence rate to the last grade of primary education (%) of Botswana in 1988 to that in 1992?
Make the answer very short. 0.92. What is the ratio of the Persistence rate to the last grade of primary education (%) in Costa Rica in 1988 to that in 1992?
Your answer should be very brief. 0.95. What is the ratio of the Persistence rate to the last grade of primary education (%) in Fragile and conflict affected situations in 1988 to that in 1993?
Keep it short and to the point. 0.94. What is the ratio of the Persistence rate to the last grade of primary education (%) of High income: OECD in 1988 to that in 1993?
Offer a terse response. 0.98. What is the ratio of the Persistence rate to the last grade of primary education (%) in Botswana in 1988 to that in 1993?
Your response must be concise. 0.86. What is the ratio of the Persistence rate to the last grade of primary education (%) of Costa Rica in 1988 to that in 1993?
Provide a short and direct response. 0.89. What is the ratio of the Persistence rate to the last grade of primary education (%) of Fragile and conflict affected situations in 1988 to that in 1994?
Keep it short and to the point. 0.94. What is the ratio of the Persistence rate to the last grade of primary education (%) in High income: OECD in 1988 to that in 1994?
Your response must be concise. 0.98. What is the ratio of the Persistence rate to the last grade of primary education (%) in Botswana in 1988 to that in 1994?
Offer a terse response. 0.82. What is the ratio of the Persistence rate to the last grade of primary education (%) of Costa Rica in 1988 to that in 1994?
Keep it short and to the point. 0.85. What is the ratio of the Persistence rate to the last grade of primary education (%) of Fragile and conflict affected situations in 1989 to that in 1991?
Provide a succinct answer. 0.96. What is the ratio of the Persistence rate to the last grade of primary education (%) in Botswana in 1989 to that in 1991?
Ensure brevity in your answer.  0.96. What is the ratio of the Persistence rate to the last grade of primary education (%) in Costa Rica in 1989 to that in 1991?
Keep it short and to the point. 1. What is the ratio of the Persistence rate to the last grade of primary education (%) in Fragile and conflict affected situations in 1989 to that in 1992?
Give a very brief answer. 0.97. What is the ratio of the Persistence rate to the last grade of primary education (%) in High income: OECD in 1989 to that in 1992?
Make the answer very short. 0.99. What is the ratio of the Persistence rate to the last grade of primary education (%) in Botswana in 1989 to that in 1992?
Offer a very short reply. 0.93. What is the ratio of the Persistence rate to the last grade of primary education (%) of Costa Rica in 1989 to that in 1992?
Your answer should be very brief. 0.99. What is the ratio of the Persistence rate to the last grade of primary education (%) of Fragile and conflict affected situations in 1989 to that in 1993?
Your answer should be very brief. 0.94. What is the ratio of the Persistence rate to the last grade of primary education (%) of Botswana in 1989 to that in 1993?
Your answer should be compact. 0.87. What is the ratio of the Persistence rate to the last grade of primary education (%) of Costa Rica in 1989 to that in 1993?
Ensure brevity in your answer.  0.92. What is the ratio of the Persistence rate to the last grade of primary education (%) of Fragile and conflict affected situations in 1989 to that in 1994?
Provide a succinct answer. 0.94. What is the ratio of the Persistence rate to the last grade of primary education (%) in High income: OECD in 1989 to that in 1994?
Your response must be concise. 0.98. What is the ratio of the Persistence rate to the last grade of primary education (%) of Botswana in 1989 to that in 1994?
Give a very brief answer. 0.83. What is the ratio of the Persistence rate to the last grade of primary education (%) in Costa Rica in 1989 to that in 1994?
Provide a succinct answer. 0.89. What is the ratio of the Persistence rate to the last grade of primary education (%) of Fragile and conflict affected situations in 1991 to that in 1992?
Provide a succinct answer. 1.01. What is the ratio of the Persistence rate to the last grade of primary education (%) in High income: OECD in 1991 to that in 1992?
Offer a very short reply. 1. What is the ratio of the Persistence rate to the last grade of primary education (%) of Botswana in 1991 to that in 1992?
Give a very brief answer. 0.97. What is the ratio of the Persistence rate to the last grade of primary education (%) of Costa Rica in 1991 to that in 1992?
Provide a succinct answer. 0.98. What is the ratio of the Persistence rate to the last grade of primary education (%) of Fragile and conflict affected situations in 1991 to that in 1993?
Your answer should be very brief. 0.98. What is the ratio of the Persistence rate to the last grade of primary education (%) of Botswana in 1991 to that in 1993?
Give a very brief answer. 0.9. What is the ratio of the Persistence rate to the last grade of primary education (%) in Costa Rica in 1991 to that in 1993?
Provide a succinct answer. 0.92. What is the ratio of the Persistence rate to the last grade of primary education (%) of Fragile and conflict affected situations in 1991 to that in 1994?
Give a very brief answer. 0.98. What is the ratio of the Persistence rate to the last grade of primary education (%) of Botswana in 1991 to that in 1994?
Ensure brevity in your answer.  0.86. What is the ratio of the Persistence rate to the last grade of primary education (%) in Costa Rica in 1991 to that in 1994?
Offer a terse response. 0.88. What is the ratio of the Persistence rate to the last grade of primary education (%) of Fragile and conflict affected situations in 1992 to that in 1993?
Provide a short and direct response. 0.97. What is the ratio of the Persistence rate to the last grade of primary education (%) in Botswana in 1992 to that in 1993?
Provide a short and direct response. 0.93. What is the ratio of the Persistence rate to the last grade of primary education (%) in Costa Rica in 1992 to that in 1993?
Give a very brief answer. 0.93. What is the ratio of the Persistence rate to the last grade of primary education (%) in Fragile and conflict affected situations in 1992 to that in 1994?
Your answer should be compact. 0.97. What is the ratio of the Persistence rate to the last grade of primary education (%) of High income: OECD in 1992 to that in 1994?
Offer a very short reply. 0.99. What is the ratio of the Persistence rate to the last grade of primary education (%) in Botswana in 1992 to that in 1994?
Your answer should be very brief. 0.89. What is the ratio of the Persistence rate to the last grade of primary education (%) of Costa Rica in 1992 to that in 1994?
Your response must be concise. 0.9. What is the ratio of the Persistence rate to the last grade of primary education (%) of Fragile and conflict affected situations in 1993 to that in 1994?
Make the answer very short. 1. What is the ratio of the Persistence rate to the last grade of primary education (%) in Botswana in 1993 to that in 1994?
Your answer should be very brief. 0.96. What is the ratio of the Persistence rate to the last grade of primary education (%) in Costa Rica in 1993 to that in 1994?
Give a very brief answer. 0.96. What is the difference between the highest and the second highest Persistence rate to the last grade of primary education (%) of Fragile and conflict affected situations?
Keep it short and to the point. 0.03. What is the difference between the highest and the second highest Persistence rate to the last grade of primary education (%) of High income: OECD?
Provide a succinct answer. 0.16. What is the difference between the highest and the second highest Persistence rate to the last grade of primary education (%) of Botswana?
Provide a short and direct response. 3.57. What is the difference between the highest and the second highest Persistence rate to the last grade of primary education (%) in Costa Rica?
Your answer should be compact. 2.96. What is the difference between the highest and the lowest Persistence rate to the last grade of primary education (%) of Fragile and conflict affected situations?
Your answer should be very brief. 3.35. What is the difference between the highest and the lowest Persistence rate to the last grade of primary education (%) of High income: OECD?
Make the answer very short. 1.97. What is the difference between the highest and the lowest Persistence rate to the last grade of primary education (%) in Botswana?
Offer a terse response. 15.2. What is the difference between the highest and the lowest Persistence rate to the last grade of primary education (%) of Costa Rica?
Your response must be concise. 10.85. 